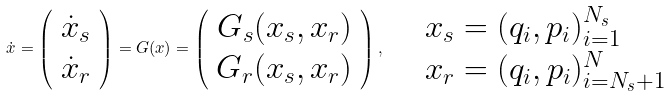<formula> <loc_0><loc_0><loc_500><loc_500>\dot { x } = \left ( \begin{array} { c } \dot { x } _ { s } \\ \dot { x } _ { r } \end{array} \right ) = G ( x ) = \left ( \begin{array} { c } G _ { s } ( x _ { s } , x _ { r } ) \\ G _ { r } ( x _ { s } , x _ { r } ) \end{array} \right ) , \quad \begin{array} { l } x _ { s } = ( { q } _ { i } , { p } _ { i } ) _ { i = 1 } ^ { N _ { s } } \\ x _ { r } = ( { q } _ { i } , { p } _ { i } ) _ { i = N _ { s } + 1 } ^ { N } \end{array}</formula> 